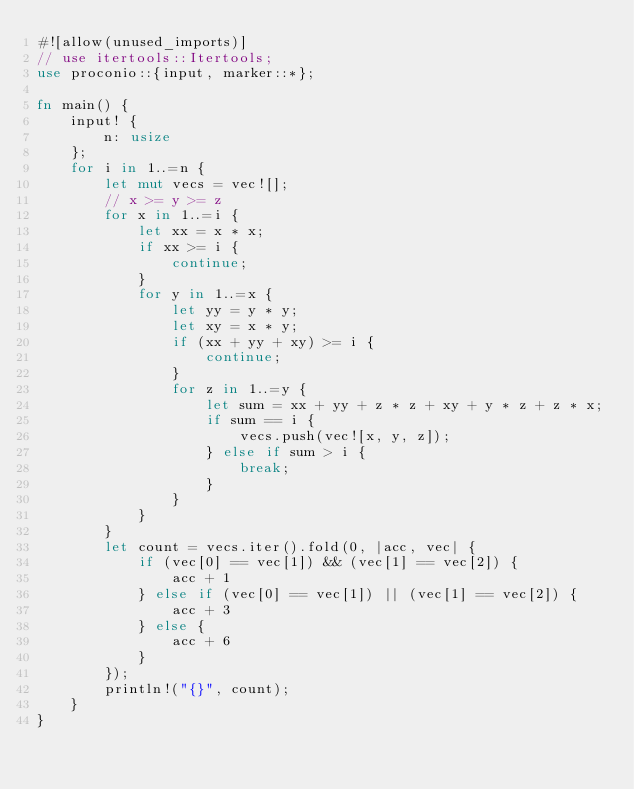<code> <loc_0><loc_0><loc_500><loc_500><_Rust_>#![allow(unused_imports)]
// use itertools::Itertools;
use proconio::{input, marker::*};

fn main() {
    input! {
        n: usize
    };
    for i in 1..=n {
        let mut vecs = vec![];
        // x >= y >= z
        for x in 1..=i {
            let xx = x * x;
            if xx >= i {
                continue;
            }
            for y in 1..=x {
                let yy = y * y;
                let xy = x * y;
                if (xx + yy + xy) >= i {
                    continue;
                }
                for z in 1..=y {
                    let sum = xx + yy + z * z + xy + y * z + z * x;
                    if sum == i {
                        vecs.push(vec![x, y, z]);
                    } else if sum > i {
                        break;
                    }
                }
            }
        }
        let count = vecs.iter().fold(0, |acc, vec| {
            if (vec[0] == vec[1]) && (vec[1] == vec[2]) {
                acc + 1
            } else if (vec[0] == vec[1]) || (vec[1] == vec[2]) {
                acc + 3
            } else {
                acc + 6
            }
        });
        println!("{}", count);
    }
}
</code> 